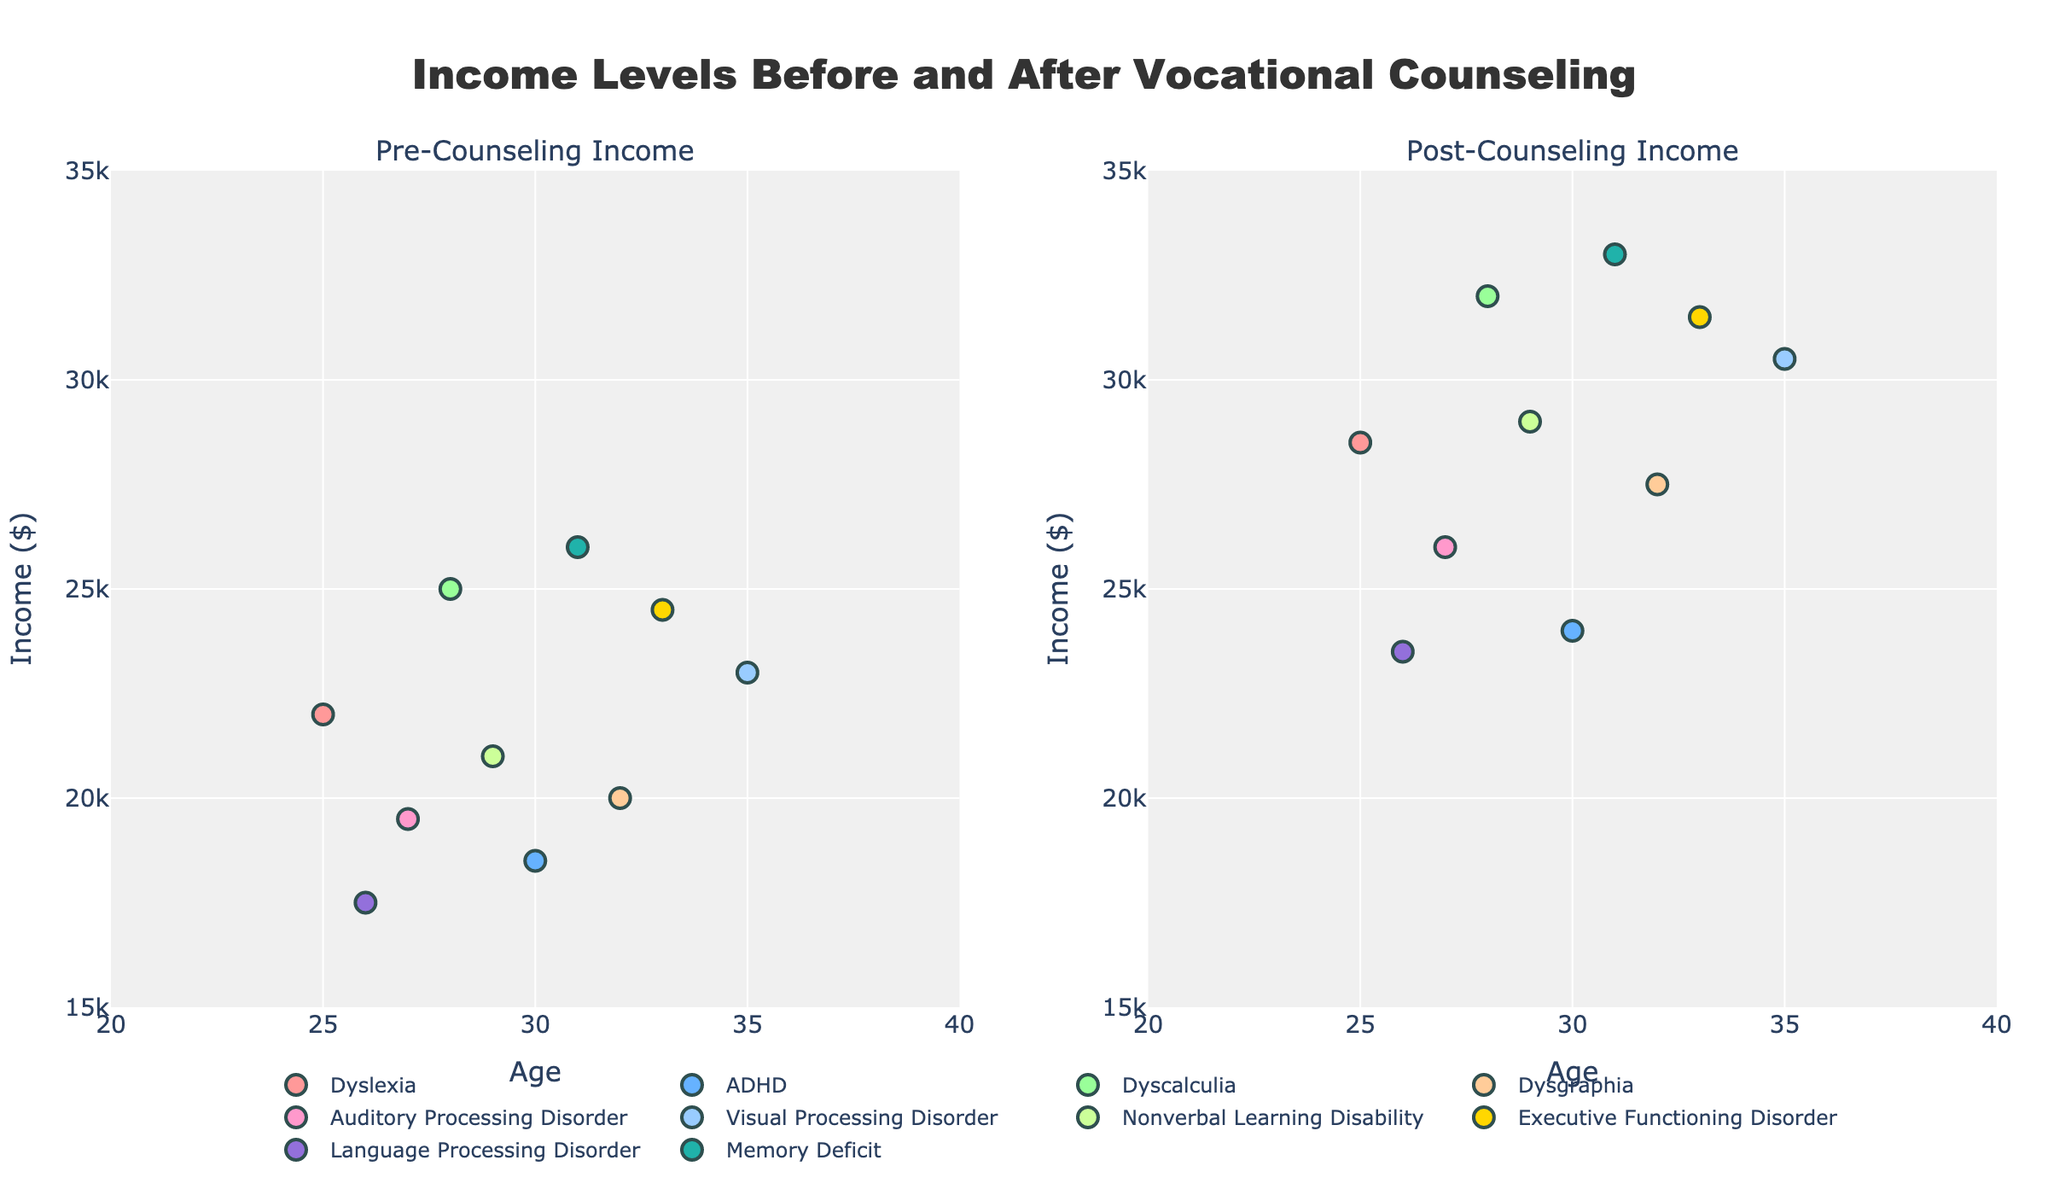How many practice areas are represented in the scatter plot matrix? Look at the legend in the scatter plot matrix, which lists all distinct practice areas represented by different colors and symbols in the plot. Count each unique entry to find the total number of practice areas.
Answer: 15 Which practice area has the highest Research Efficiency? Locate the Research Efficiency dimension on the scatter plot matrix. Identify the highest value along this axis and note the corresponding practice area, which will be indicated by the assigned color and symbol.
Answer: Labor Law Is Case Prep Time generally higher or lower for Corporate Law compared to Criminal Defense? Find the data points for Corporate Law and Criminal Defense along the Case Prep Time axis. Compare their positions to determine whether the value for Corporate Law is higher or lower than that of Criminal Defense.
Answer: Lower Which practice area has the highest Courtroom Performance, and what is the corresponding Research Efficiency? Identify the data point with the highest value on the Courtroom Performance axis. Track that point horizontally to the Research Efficiency axis to find the corresponding value and note the practice area indicated by the symbol and color.
Answer: Mergers and Acquisitions, 90 What is the median Case Prep Time across all practice areas? To compute the median, list all Case Prep Time values in ascending order: 85, 90, 95, 95, 100, 105, 105, 110, 115, 120, 125, 130, 135, 140, 150. The median is the middle value, so count to the 8th value.
Answer: 110 Compare the Research Efficiency of Healthcare Law and Real Estate. Which has a higher value? Locate the data points for Healthcare Law and Real Estate along the Research Efficiency axis. Compare their positions to determine which one is higher.
Answer: Healthcare Law Are there any practice areas with the exact same Case Prep Time? If so, which ones? Look for overlapping data points along the Case Prep Time axis. Identify any pairs or groups of practice areas that share the same value. Check for any symbols and colors that overlap vertically.
Answer: Intellectual Property and Civil Rights; Labor Law and Healthcare Law Which practice area has the lowest Research Efficiency, and what is their Case Prep Time? Identify the data point with the lowest value along the Research Efficiency axis and find the corresponding Case Prep Time value by looking horizontally at the match. Note the practice area by observing the symbol or color.
Answer: Criminal Defense, 150 What is the relationship between Case Prep Time and Courtroom Performance? Examine the scatter plots where Case Prep Time and Courtroom Performance are plotted against each other. Analyze the trend—whether it appears linear, inverse, or random—to determine the relationship.
Answer: Generally inverse 